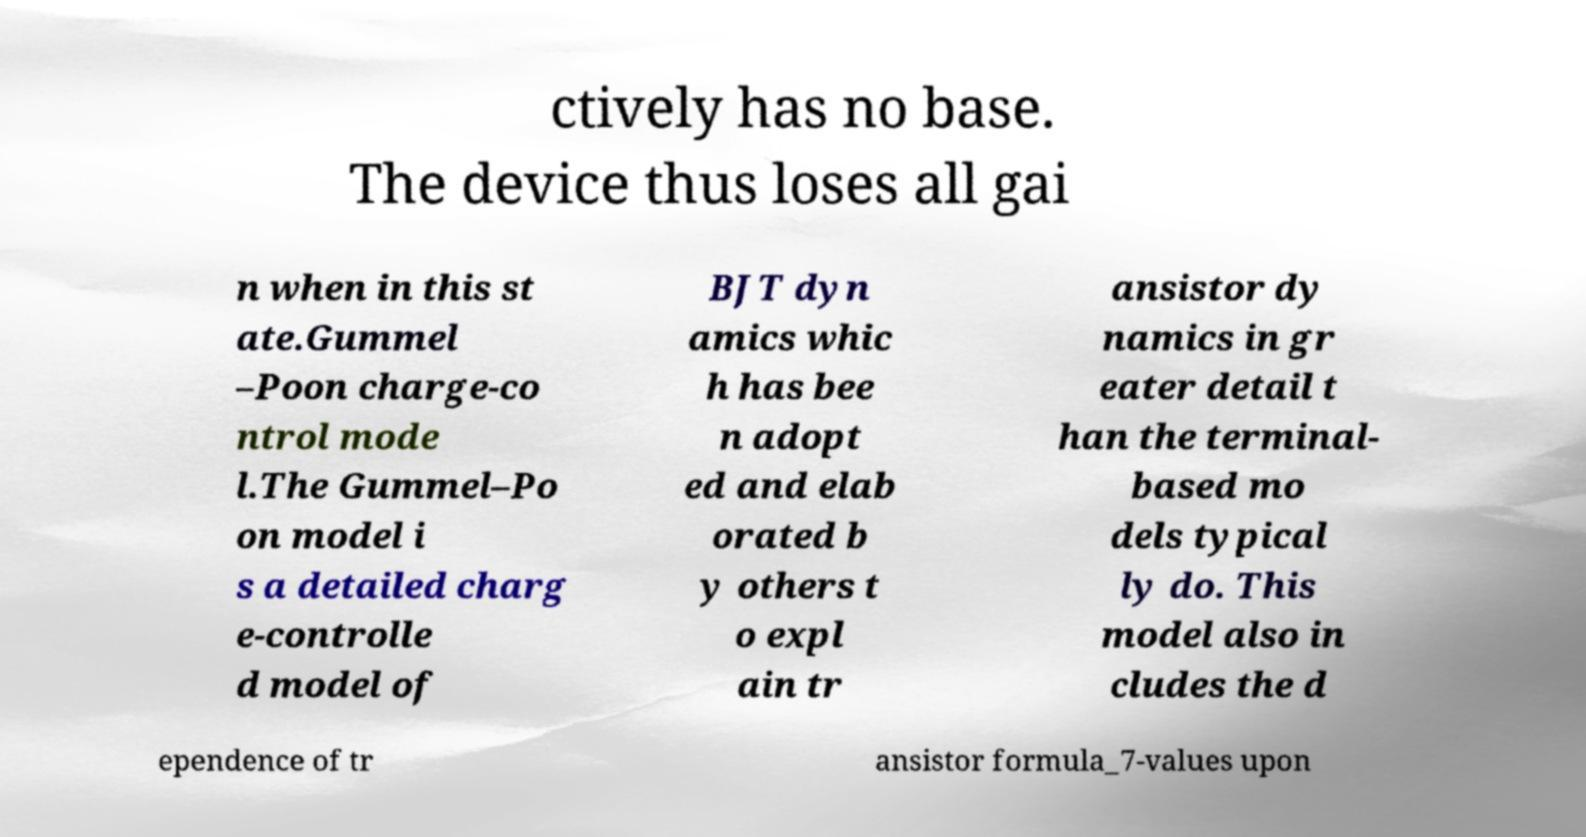Could you extract and type out the text from this image? ctively has no base. The device thus loses all gai n when in this st ate.Gummel –Poon charge-co ntrol mode l.The Gummel–Po on model i s a detailed charg e-controlle d model of BJT dyn amics whic h has bee n adopt ed and elab orated b y others t o expl ain tr ansistor dy namics in gr eater detail t han the terminal- based mo dels typical ly do. This model also in cludes the d ependence of tr ansistor formula_7-values upon 